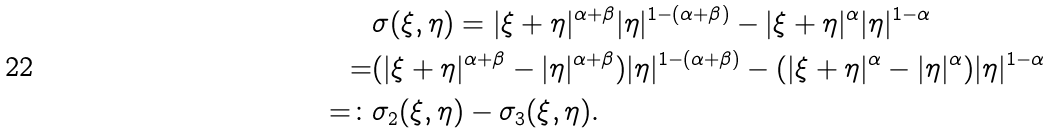Convert formula to latex. <formula><loc_0><loc_0><loc_500><loc_500>& \sigma ( \xi , \eta ) = | \xi + \eta | ^ { \alpha + \beta } | \eta | ^ { 1 - ( \alpha + \beta ) } - | \xi + \eta | ^ { \alpha } | \eta | ^ { 1 - \alpha } \\ = & ( | \xi + \eta | ^ { \alpha + \beta } - | \eta | ^ { \alpha + \beta } ) | \eta | ^ { 1 - ( \alpha + \beta ) } - ( | \xi + \eta | ^ { \alpha } - | \eta | ^ { \alpha } ) | \eta | ^ { 1 - \alpha } \\ = \colon & \sigma _ { 2 } ( \xi , \eta ) - \sigma _ { 3 } ( \xi , \eta ) .</formula> 